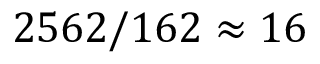<formula> <loc_0><loc_0><loc_500><loc_500>2 5 6 2 / 1 6 2 \approx 1 6</formula> 